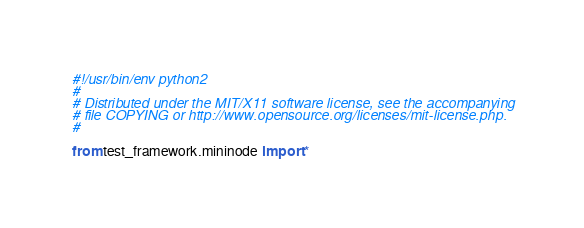<code> <loc_0><loc_0><loc_500><loc_500><_Python_>#!/usr/bin/env python2
#
# Distributed under the MIT/X11 software license, see the accompanying
# file COPYING or http://www.opensource.org/licenses/mit-license.php.
#

from test_framework.mininode import *</code> 